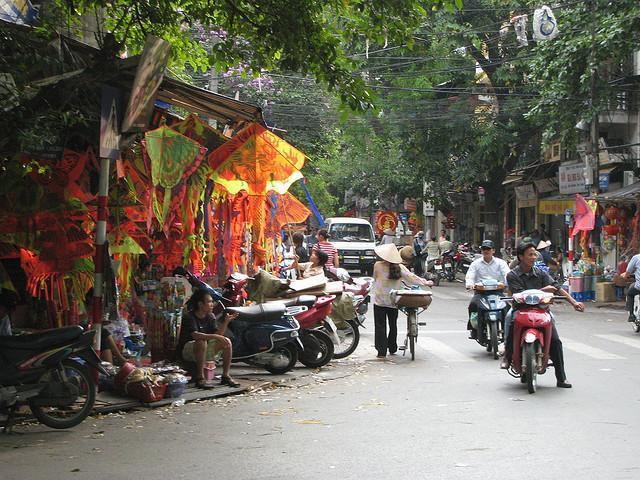How many kites are in the photo?
Give a very brief answer. 4. How many people can be seen?
Give a very brief answer. 4. How many motorcycles are there?
Give a very brief answer. 5. 